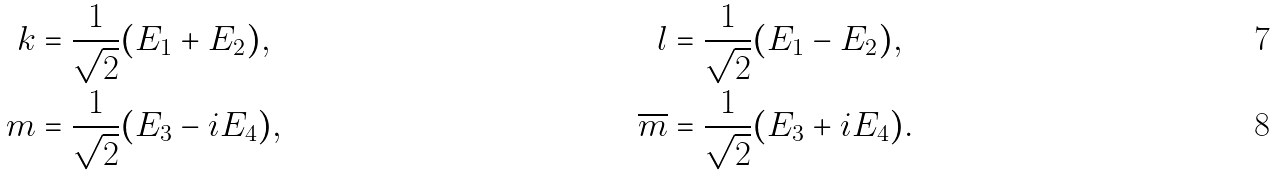Convert formula to latex. <formula><loc_0><loc_0><loc_500><loc_500>k & = \frac { 1 } { \sqrt { 2 } } ( E _ { 1 } + E _ { 2 } ) , & l & = \frac { 1 } { \sqrt { 2 } } ( E _ { 1 } - E _ { 2 } ) , \\ m & = \frac { 1 } { \sqrt { 2 } } ( E _ { 3 } - i E _ { 4 } ) , & \overline { m } & = \frac { 1 } { \sqrt { 2 } } ( E _ { 3 } + i E _ { 4 } ) .</formula> 